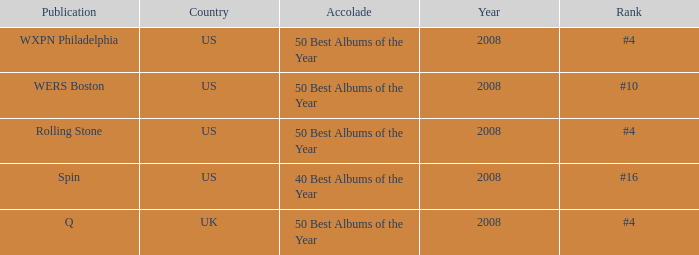Which issuance occurred in the uk? Q. 